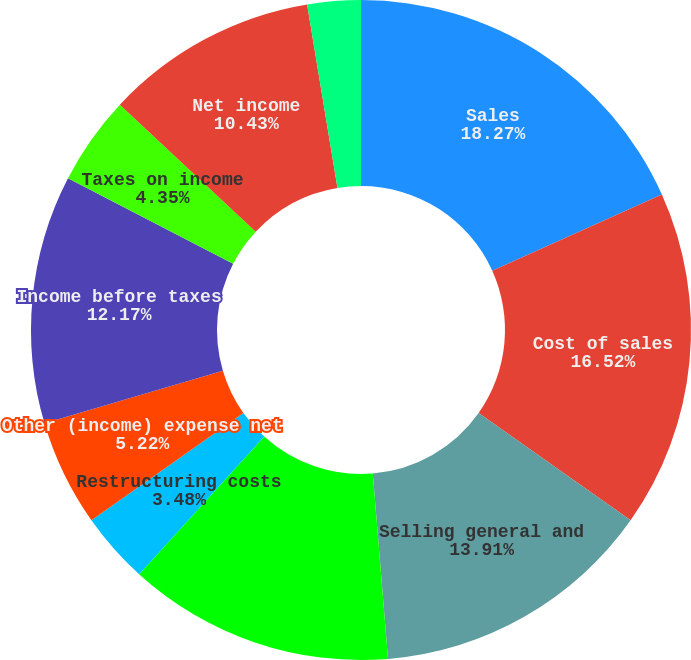<chart> <loc_0><loc_0><loc_500><loc_500><pie_chart><fcel>Sales<fcel>Cost of sales<fcel>Selling general and<fcel>Research and development<fcel>Restructuring costs<fcel>Other (income) expense net<fcel>Income before taxes<fcel>Taxes on income<fcel>Net income<fcel>Less Net (loss) income<nl><fcel>18.26%<fcel>16.52%<fcel>13.91%<fcel>13.04%<fcel>3.48%<fcel>5.22%<fcel>12.17%<fcel>4.35%<fcel>10.43%<fcel>2.61%<nl></chart> 